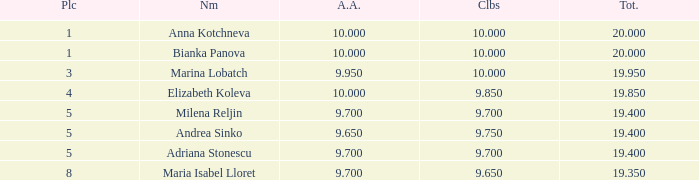How many places have bianka panova as the name, with clubs less than 10? 0.0. 